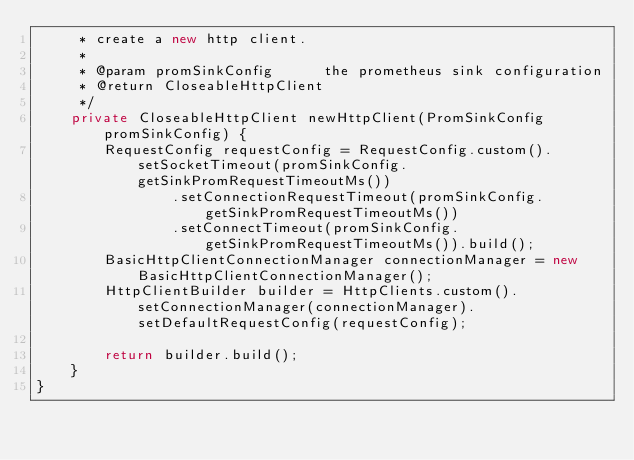<code> <loc_0><loc_0><loc_500><loc_500><_Java_>     * create a new http client.
     *
     * @param promSinkConfig      the prometheus sink configuration
     * @return CloseableHttpClient
     */
    private CloseableHttpClient newHttpClient(PromSinkConfig promSinkConfig) {
        RequestConfig requestConfig = RequestConfig.custom().setSocketTimeout(promSinkConfig.getSinkPromRequestTimeoutMs())
                .setConnectionRequestTimeout(promSinkConfig.getSinkPromRequestTimeoutMs())
                .setConnectTimeout(promSinkConfig.getSinkPromRequestTimeoutMs()).build();
        BasicHttpClientConnectionManager connectionManager = new BasicHttpClientConnectionManager();
        HttpClientBuilder builder = HttpClients.custom().setConnectionManager(connectionManager).setDefaultRequestConfig(requestConfig);

        return builder.build();
    }
}
</code> 